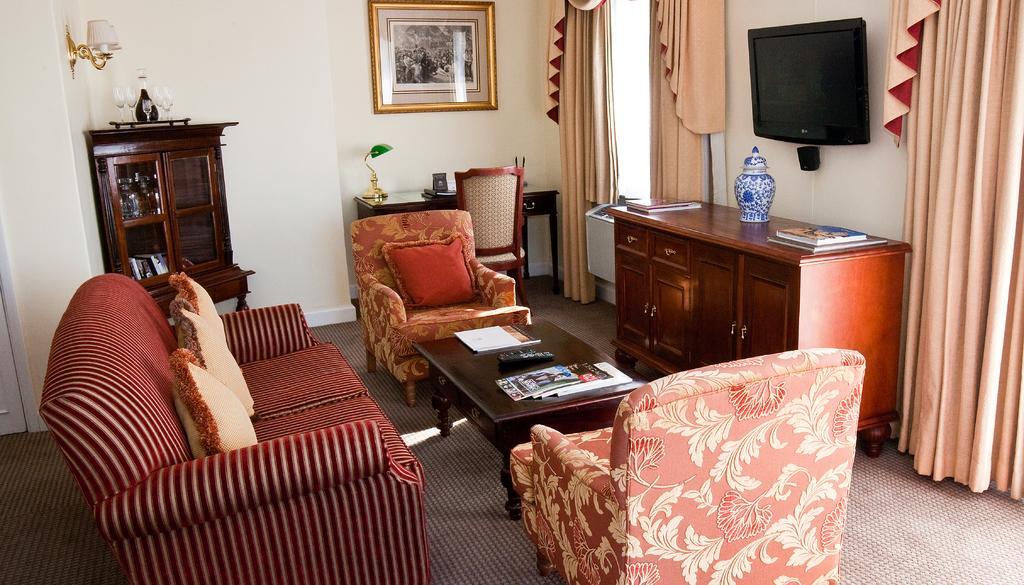In one or two sentences, can you explain what this image depicts? This is a room. There is sofa two chairs. There is carpet on the floor. In the middle there is a wooden table. On the table there are few books and a remote control. There is a table a chair and a table lamp. There is cupboard inside it there are books on the table there are glasses and a bottle. There is a photo frame hanged on the wall. The wall is white in color. There is another cupboard in the right side of the picture. On that there are books and there are few drawer in the cupboard. There is a television. On the cupboard there is a pot. There are cushions on the sofa and chair. There are cream colored curtains. There is window. 